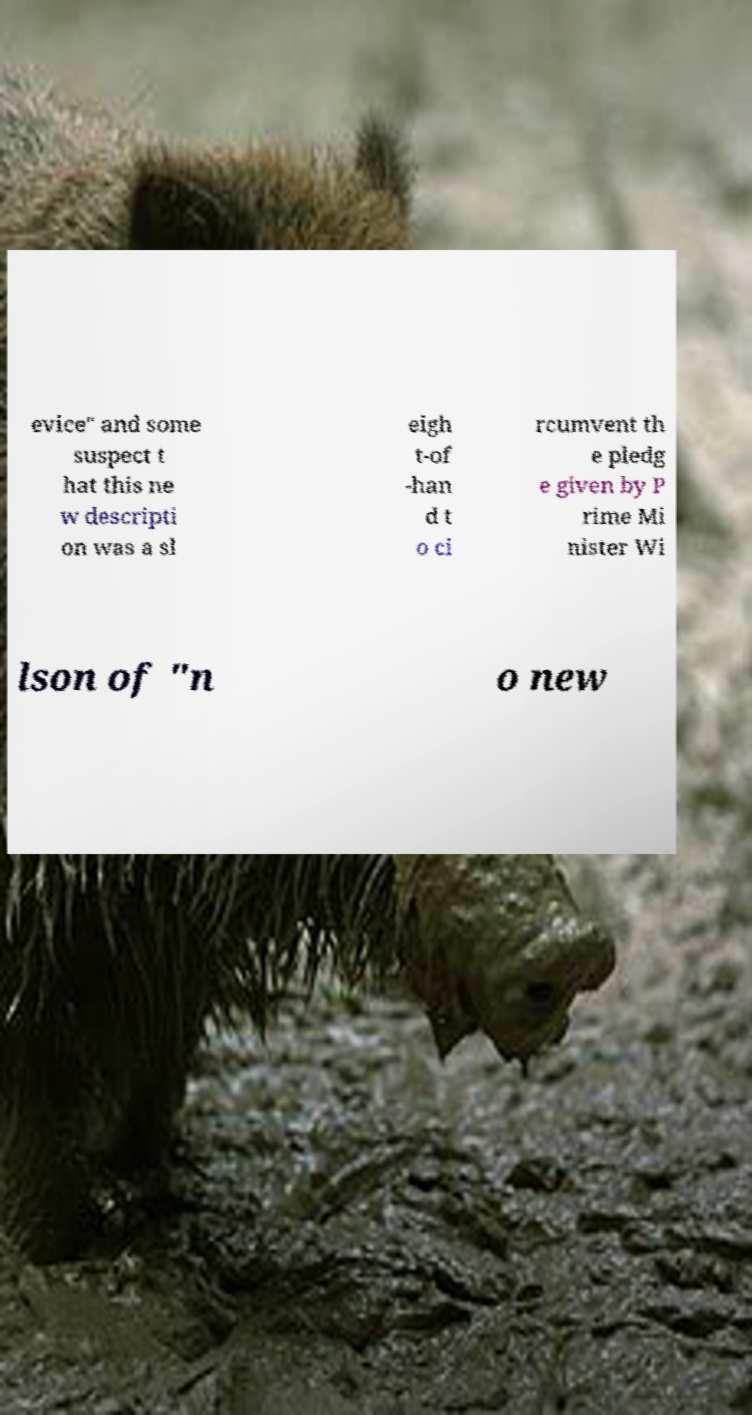There's text embedded in this image that I need extracted. Can you transcribe it verbatim? evice" and some suspect t hat this ne w descripti on was a sl eigh t-of -han d t o ci rcumvent th e pledg e given by P rime Mi nister Wi lson of "n o new 